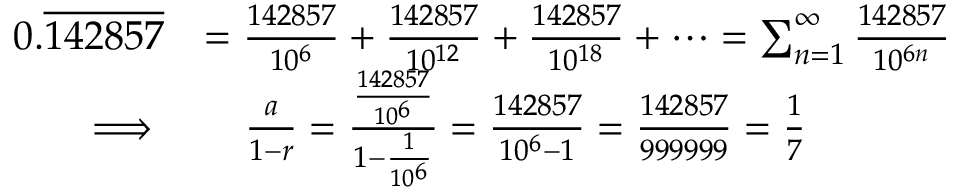<formula> <loc_0><loc_0><loc_500><loc_500>{ \begin{array} { r l } { 0 . { \overline { 1 4 2 8 5 7 } } } & { = { \frac { 1 4 2 8 5 7 } { 1 0 ^ { 6 } } } + { \frac { 1 4 2 8 5 7 } { 1 0 ^ { 1 2 } } } + { \frac { 1 4 2 8 5 7 } { 1 0 ^ { 1 8 } } } + \cdots = \sum _ { n = 1 } ^ { \infty } { \frac { 1 4 2 8 5 7 } { 1 0 ^ { 6 n } } } } \\ { \implies } & { \quad \frac { a } { 1 - r } = { \frac { \frac { 1 4 2 8 5 7 } { 1 0 ^ { 6 } } } { 1 - { \frac { 1 } { 1 0 ^ { 6 } } } } } = { \frac { 1 4 2 8 5 7 } { 1 0 ^ { 6 } - 1 } } = { \frac { 1 4 2 8 5 7 } { 9 9 9 9 9 9 } } = { \frac { 1 } { 7 } } } \end{array} }</formula> 